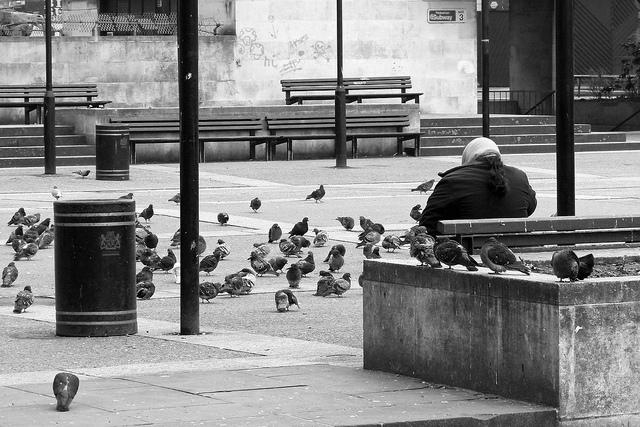Why are all the pigeons around the woman? feeding them 